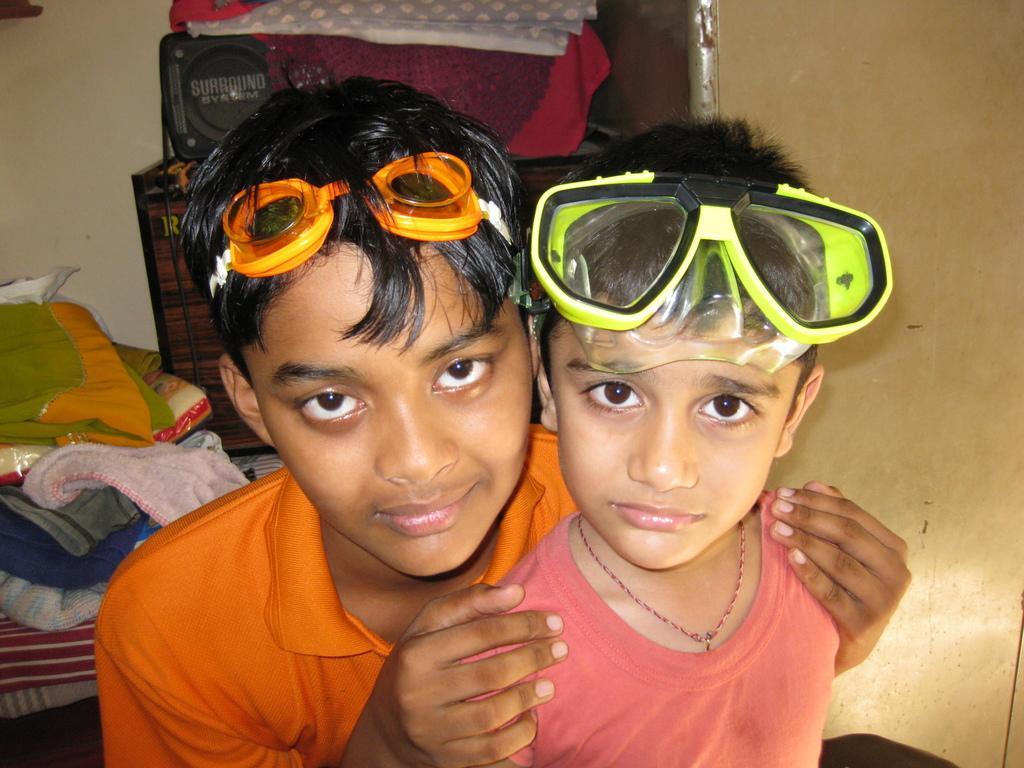How would you summarize this image in a sentence or two? In this image I can see a two people. They are wearing red and orange color dress and also wearing glasses. Background I can see few clothes and some objects. I can see a wall. 